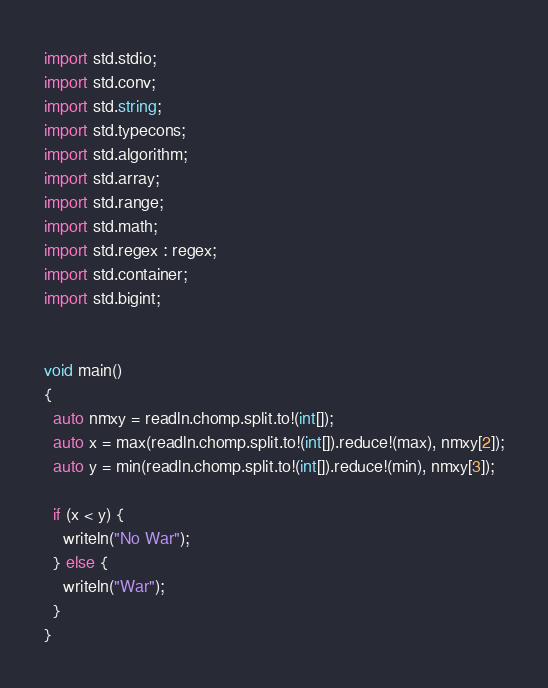<code> <loc_0><loc_0><loc_500><loc_500><_D_>import std.stdio;
import std.conv;
import std.string;
import std.typecons;
import std.algorithm;
import std.array;
import std.range;
import std.math;
import std.regex : regex;
import std.container;
import std.bigint;


void main()
{
  auto nmxy = readln.chomp.split.to!(int[]);
  auto x = max(readln.chomp.split.to!(int[]).reduce!(max), nmxy[2]);
  auto y = min(readln.chomp.split.to!(int[]).reduce!(min), nmxy[3]);

  if (x < y) {
    writeln("No War");
  } else {
    writeln("War");
  }
}
</code> 